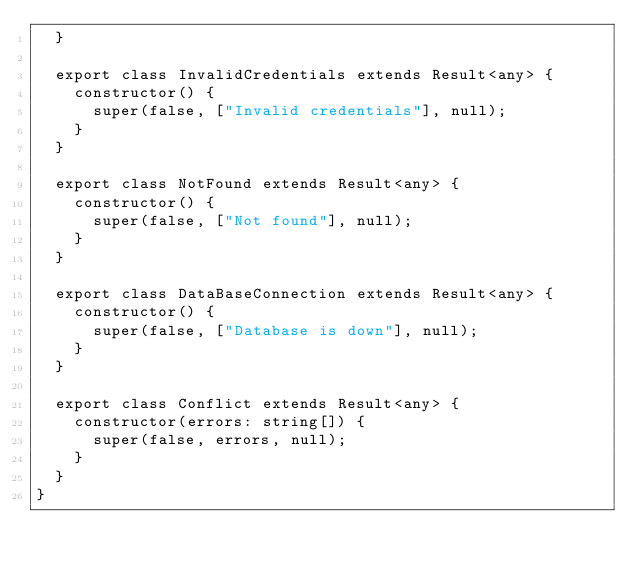Convert code to text. <code><loc_0><loc_0><loc_500><loc_500><_TypeScript_>  }

  export class InvalidCredentials extends Result<any> {
    constructor() {
      super(false, ["Invalid credentials"], null);
    }
  }

  export class NotFound extends Result<any> {
    constructor() {
      super(false, ["Not found"], null);
    }
  }

  export class DataBaseConnection extends Result<any> {
    constructor() {
      super(false, ["Database is down"], null);
    }
  }

  export class Conflict extends Result<any> {
    constructor(errors: string[]) {
      super(false, errors, null);
    }
  }
}
</code> 